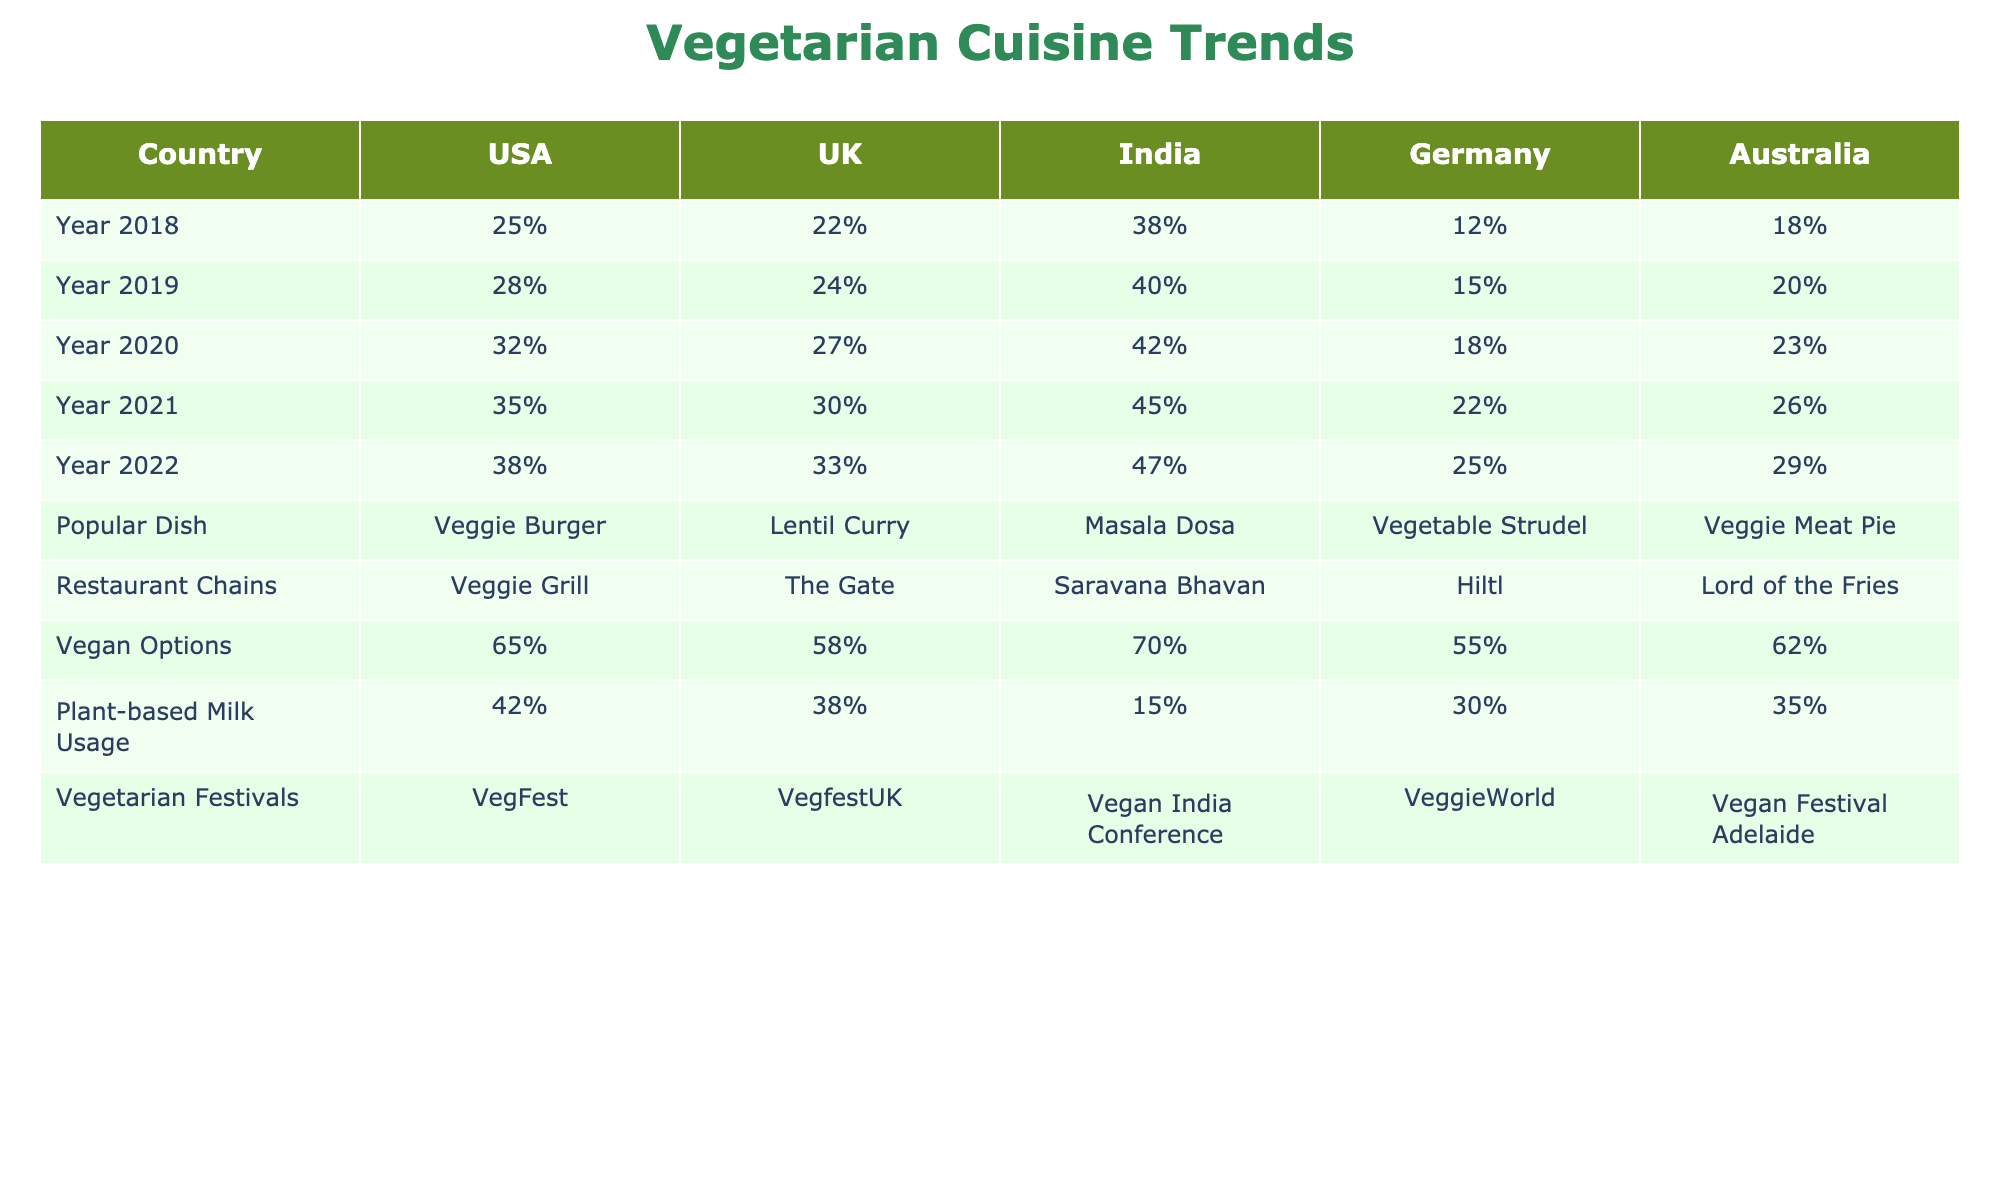What was the percentage of vegetarian cuisine popularity in the USA in 2022? In the table, under the USA column and the Year 2022 row, the percentage listed is 38%.
Answer: 38% Which country had the highest percentage of vegetarian cuisine popularity in 2021? By checking the percentages for each country in the Year 2021 row, India's popularity is 45%, which is higher than the other countries listed.
Answer: India What is the popular vegetarian dish in the UK? The table lists "Lentil Curry" as the popular vegetarian dish in the UK under the Popular Dish row.
Answer: Lentil Curry In which year did Australia have the lowest percentage of vegetarian cuisine popularity? Looking at Australia's percentages from 2018 to 2022, the lowest value is 18% in 2018.
Answer: 2018 What is the average percentage of vegetarian cuisine popularity in Germany from 2018 to 2022? To find the average, sum the percentages for Germany (12% + 15% + 18% + 22% + 25% = 92%) and divide by the number of years (5). The average is 92% / 5 = 18.4%.
Answer: 18.4% Did the percentage of vegetarian cuisine popularity increase in the USA from 2018 to 2022? The percentages for the USA in those years are 25% (2018) and 38% (2022), showing an increase over these years.
Answer: Yes Which country had more vegan options, Germany or Australia? The table shows that Germany has 55% vegan options, whereas Australia has 62%. Since 62% is greater than 55%, Australia has more.
Answer: Australia What was the increase in the percentage of vegetarian cuisine popularity in India from 2018 to 2022? The percentage in India changed from 38% in 2018 to 47% in 2022. The increase is calculated by subtracting the two values (47% - 38% = 9%).
Answer: 9% Is it true that the USA had more plant-based milk usage than the UK in 2022? For 2022, the table indicates plant-based milk usage of 42% in the USA and 38% in the UK. Since 42% is greater than 38%, the statement is true.
Answer: True What is the difference in vegetarian cuisine popularity between the USA and Germany in 2020? In 2020, the USA had a popularity of 32%, and Germany had 18%. The difference is (32% - 18% = 14%).
Answer: 14% 